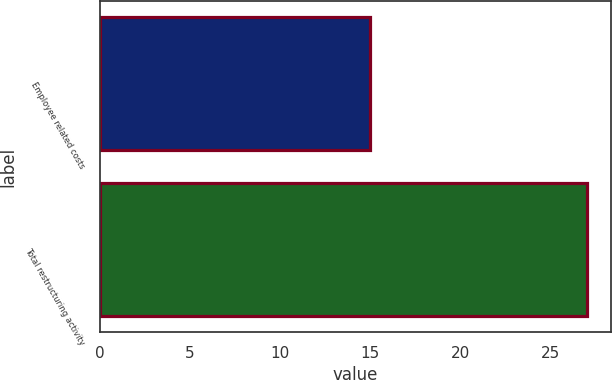Convert chart to OTSL. <chart><loc_0><loc_0><loc_500><loc_500><bar_chart><fcel>Employee related costs<fcel>Total restructuring activity<nl><fcel>15<fcel>27<nl></chart> 